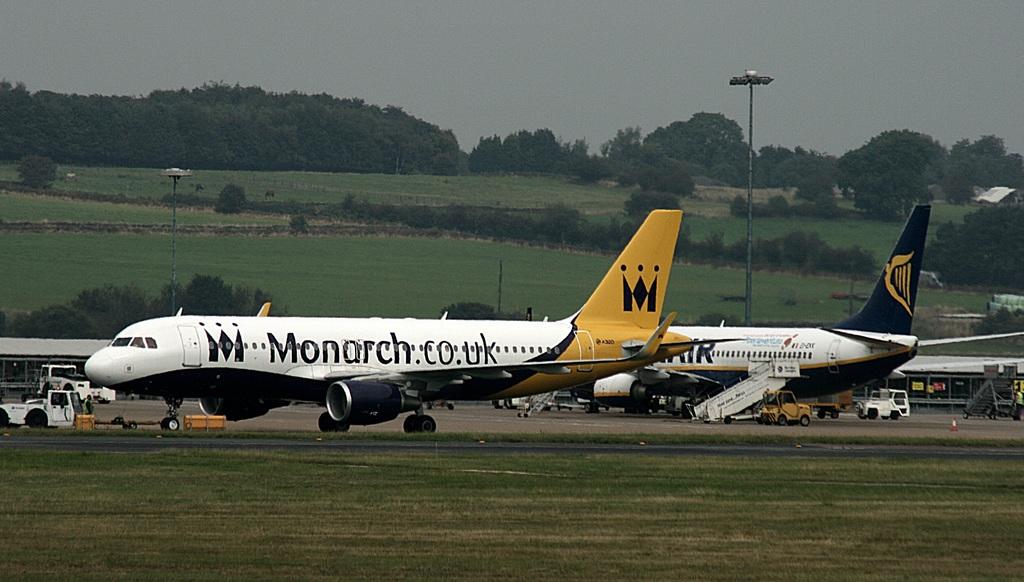What is this planes website?
Keep it short and to the point. Monarch.co.uk. What letter is the symbol on the tale of the plane?
Provide a succinct answer. M. 